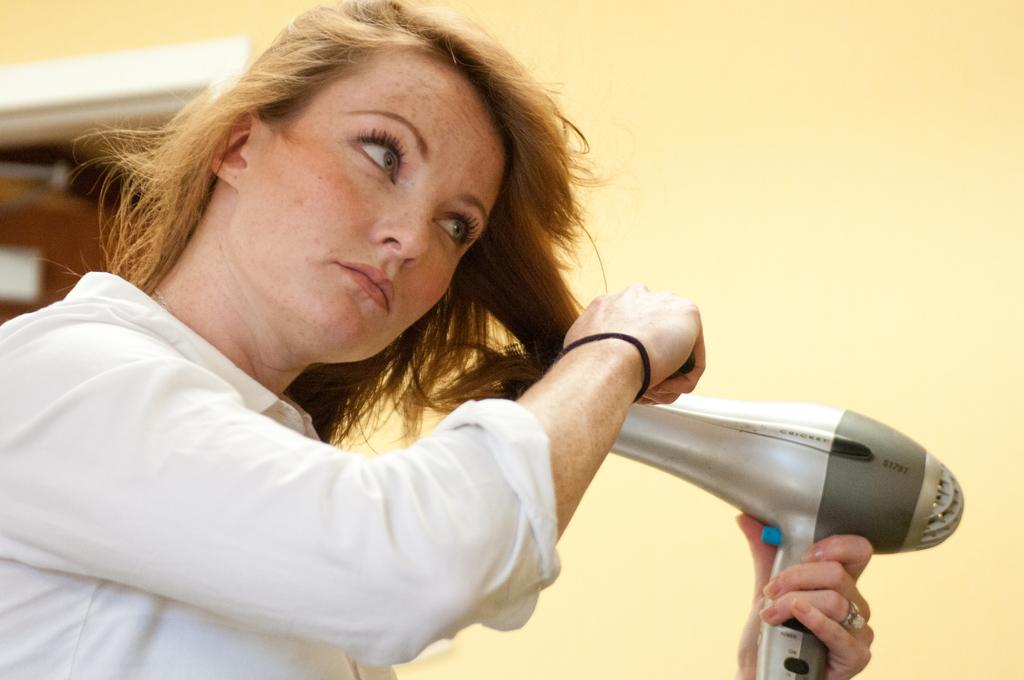What is the person in the image doing? The person is holding a hair dryer. What can be seen in the background of the image? There is a wall in the background of the image. Where is the door located in the image? The door is on the left side of the image. What arithmetic problem is the person solving in the image? There is no arithmetic problem present in the image; the person is holding a hair dryer. What type of wood can be seen in the image? There is no wood visible in the image. 